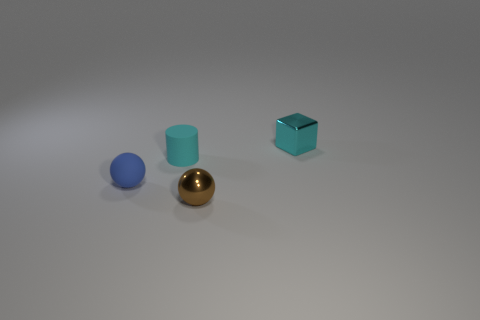How does the lighting in the image affect the appearance of the objects? The lighting in the image creates a soft shadow on the left side of the objects, suggesting a light source from the top-right. The matte surfaces of the blue sphere and the teal cylinder absorb light, reducing reflectivity, while the golden sphere has a high shine that highlights its curvature. The cube, with its glossy finish, reflects the light sharply, making its edges and surface quite prominent. 